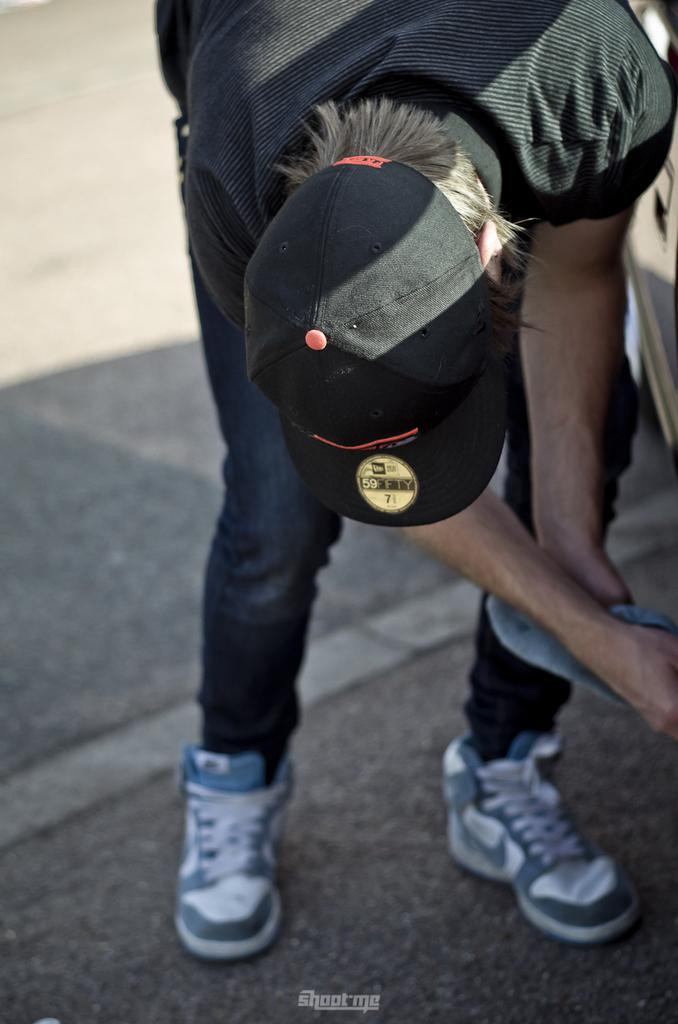What can be seen in the image related to a person? There is a person in the image. What is the person wearing on their head? The person is wearing a black cap. What is the person wearing on their upper body? The person is wearing a black t-shirt. What is the person wearing on their lower body? The person is wearing jeans. What is the person wearing on their feet? The person is wearing shoes. What is visible in the image that might indicate a path or direction? There is a path visible in the image. How many hands are visible in the image? There are no hands visible in the image; only the person's clothing and the path are present. 